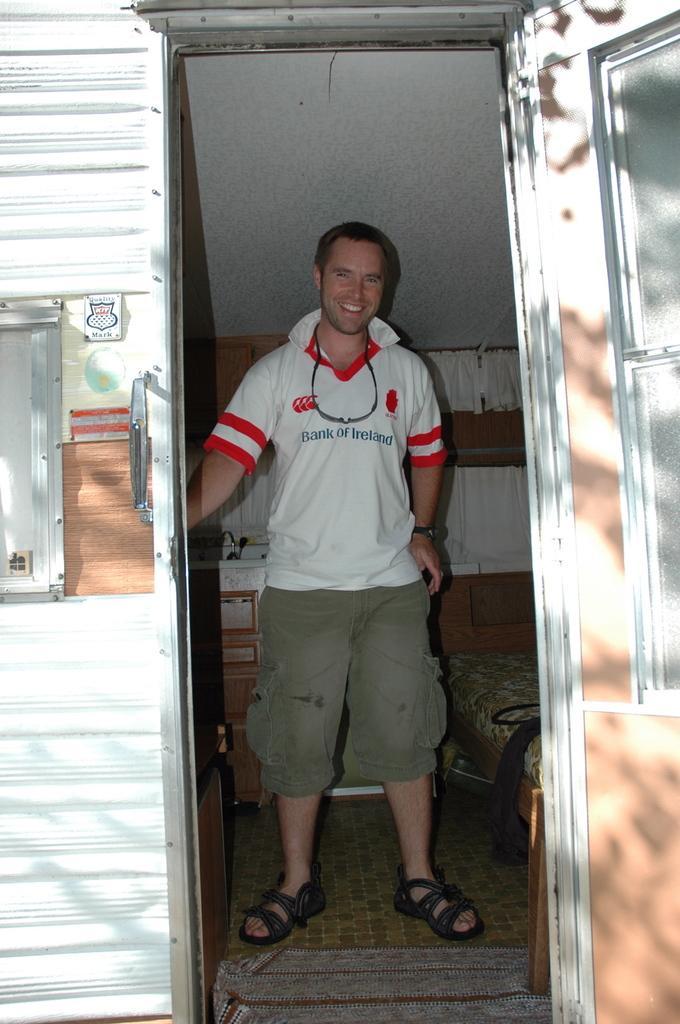Could you give a brief overview of what you see in this image? Here I can see a man standing inside a room, smiling and giving pose for the picture. On the right side there is a window to the wall. On the left side there is a door. Beside this man there is a bed. 